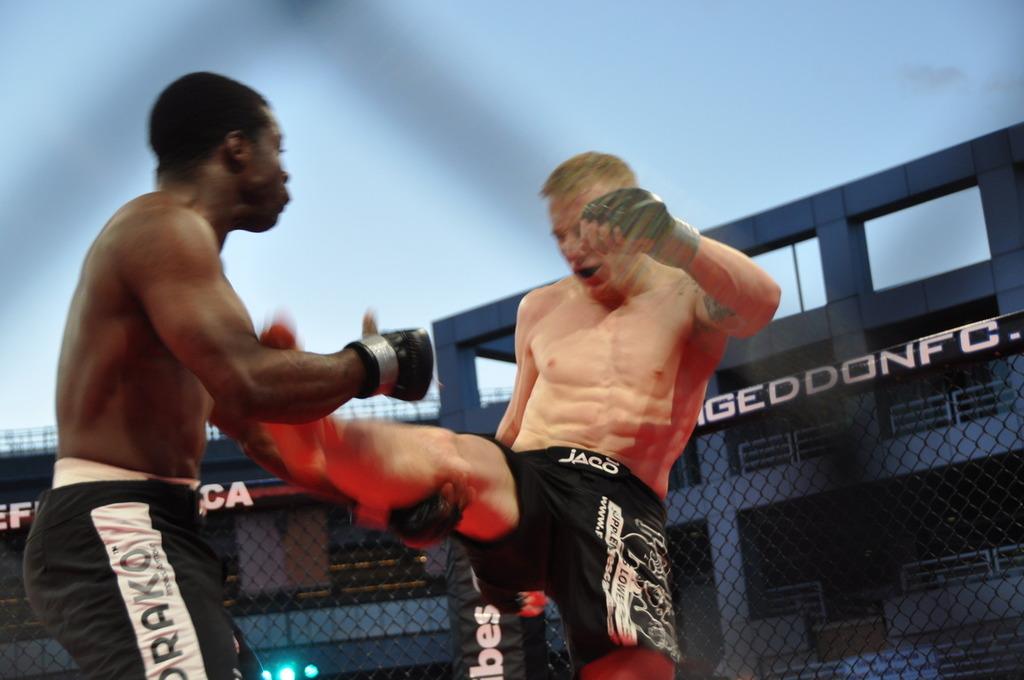What brand shorts is the white guy wearing?
Keep it short and to the point. Jaco. What letter can be seen at the end of the word in the background?
Provide a short and direct response. C. 